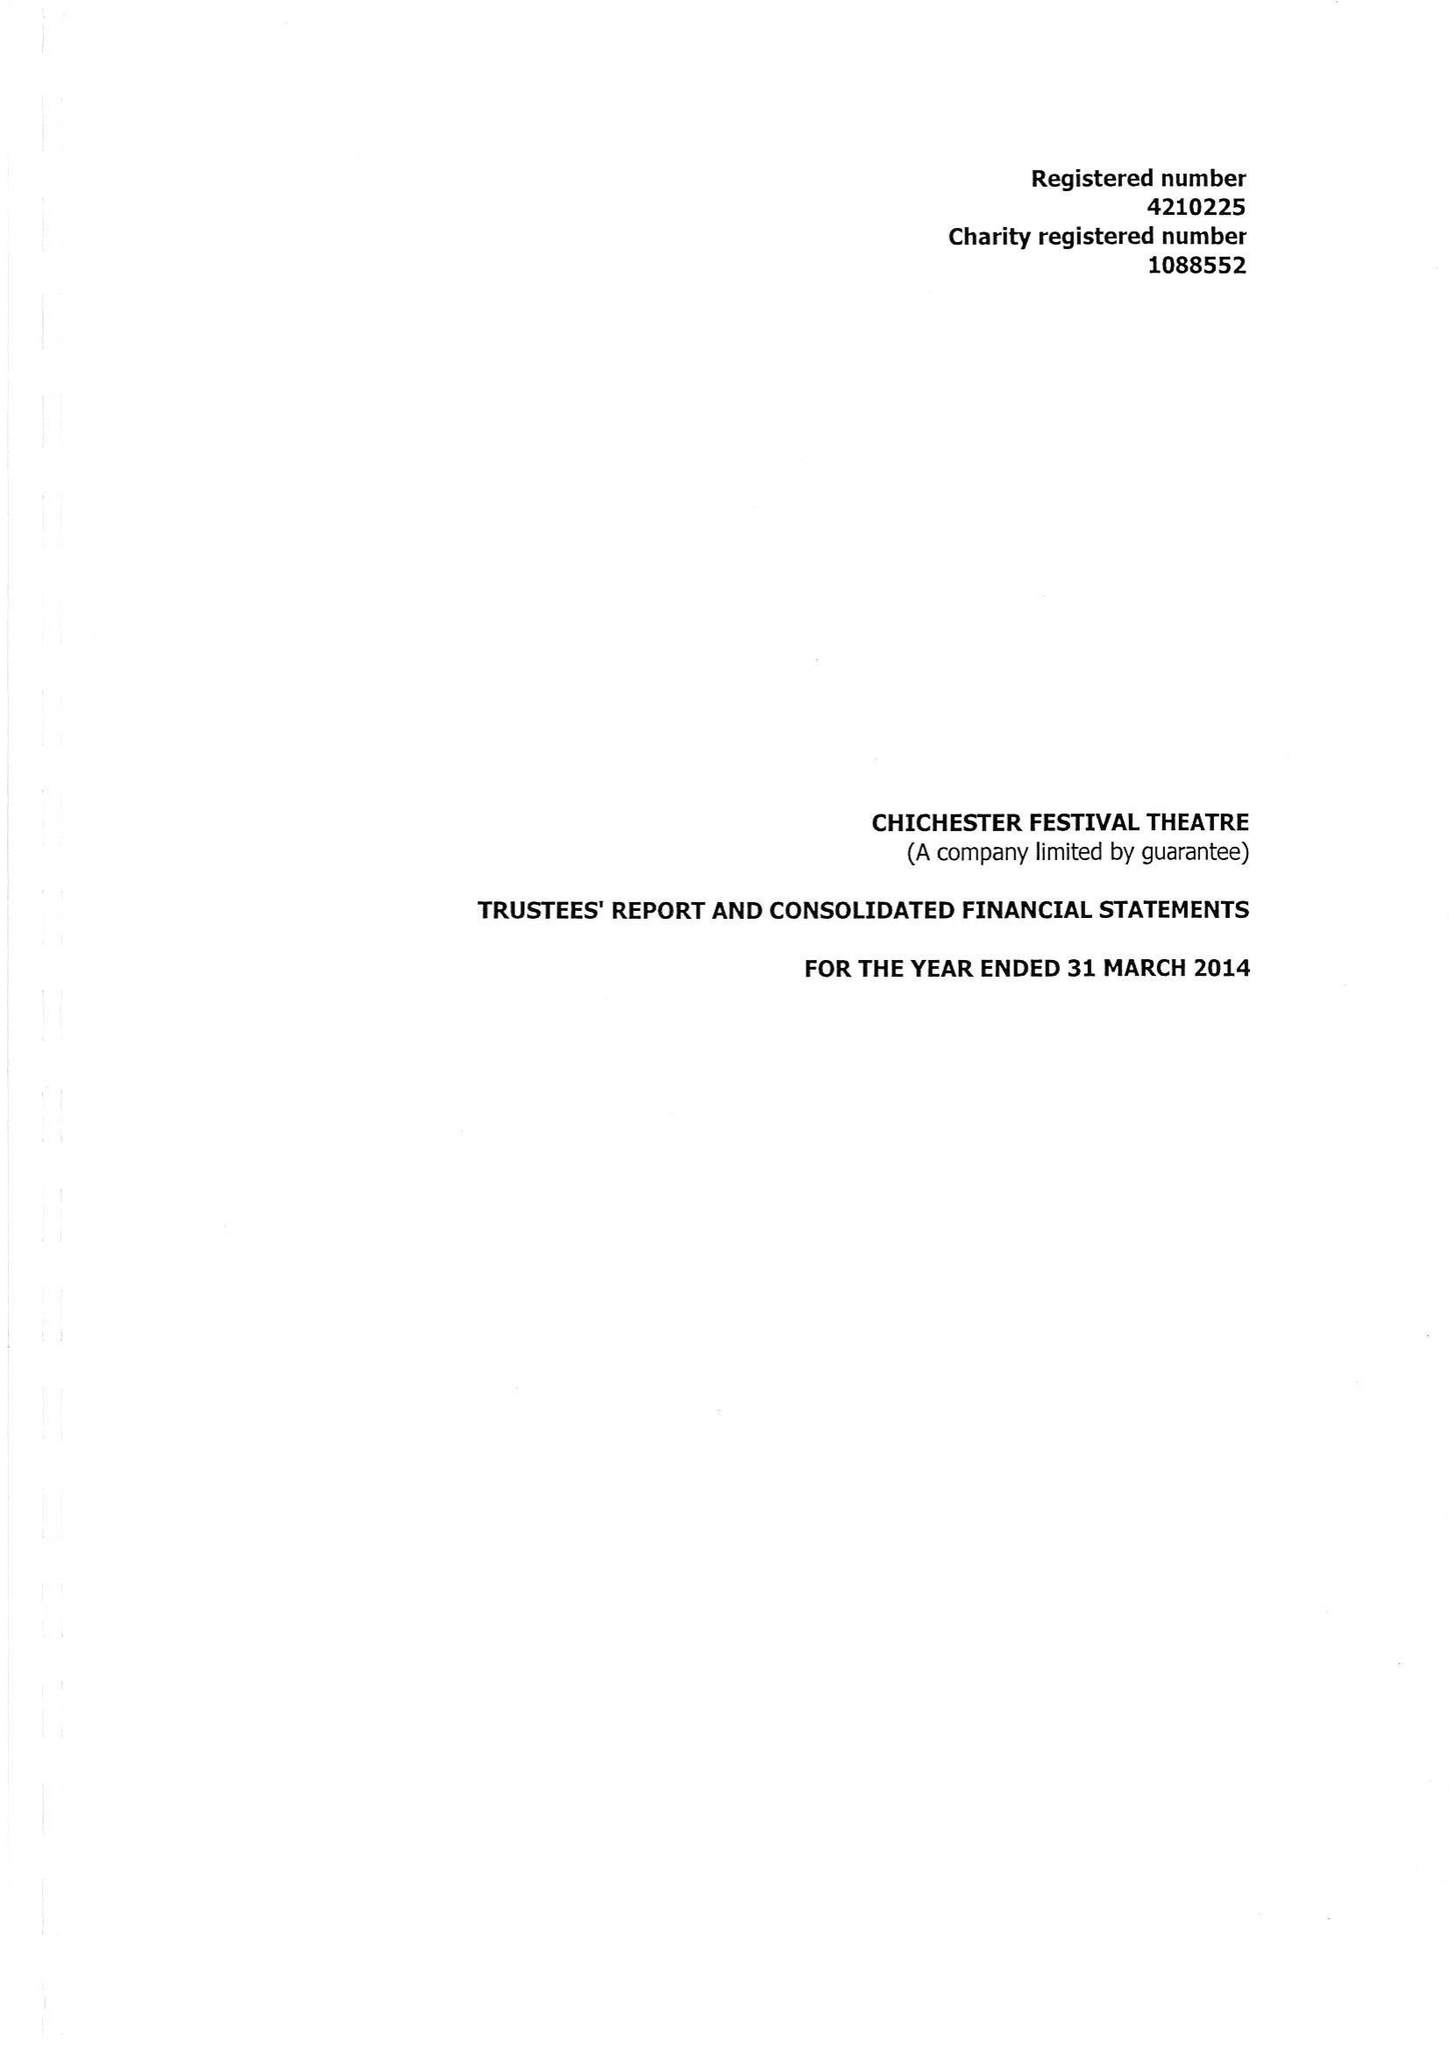What is the value for the charity_number?
Answer the question using a single word or phrase. 1088552 